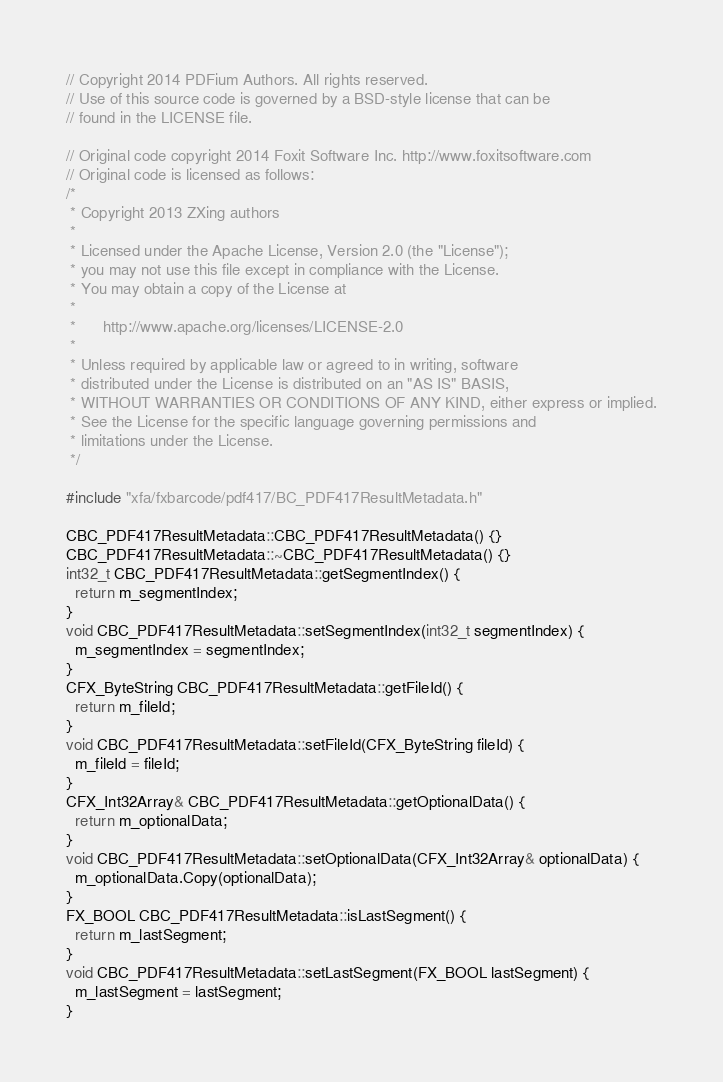Convert code to text. <code><loc_0><loc_0><loc_500><loc_500><_C++_>// Copyright 2014 PDFium Authors. All rights reserved.
// Use of this source code is governed by a BSD-style license that can be
// found in the LICENSE file.

// Original code copyright 2014 Foxit Software Inc. http://www.foxitsoftware.com
// Original code is licensed as follows:
/*
 * Copyright 2013 ZXing authors
 *
 * Licensed under the Apache License, Version 2.0 (the "License");
 * you may not use this file except in compliance with the License.
 * You may obtain a copy of the License at
 *
 *      http://www.apache.org/licenses/LICENSE-2.0
 *
 * Unless required by applicable law or agreed to in writing, software
 * distributed under the License is distributed on an "AS IS" BASIS,
 * WITHOUT WARRANTIES OR CONDITIONS OF ANY KIND, either express or implied.
 * See the License for the specific language governing permissions and
 * limitations under the License.
 */

#include "xfa/fxbarcode/pdf417/BC_PDF417ResultMetadata.h"

CBC_PDF417ResultMetadata::CBC_PDF417ResultMetadata() {}
CBC_PDF417ResultMetadata::~CBC_PDF417ResultMetadata() {}
int32_t CBC_PDF417ResultMetadata::getSegmentIndex() {
  return m_segmentIndex;
}
void CBC_PDF417ResultMetadata::setSegmentIndex(int32_t segmentIndex) {
  m_segmentIndex = segmentIndex;
}
CFX_ByteString CBC_PDF417ResultMetadata::getFileId() {
  return m_fileId;
}
void CBC_PDF417ResultMetadata::setFileId(CFX_ByteString fileId) {
  m_fileId = fileId;
}
CFX_Int32Array& CBC_PDF417ResultMetadata::getOptionalData() {
  return m_optionalData;
}
void CBC_PDF417ResultMetadata::setOptionalData(CFX_Int32Array& optionalData) {
  m_optionalData.Copy(optionalData);
}
FX_BOOL CBC_PDF417ResultMetadata::isLastSegment() {
  return m_lastSegment;
}
void CBC_PDF417ResultMetadata::setLastSegment(FX_BOOL lastSegment) {
  m_lastSegment = lastSegment;
}
</code> 